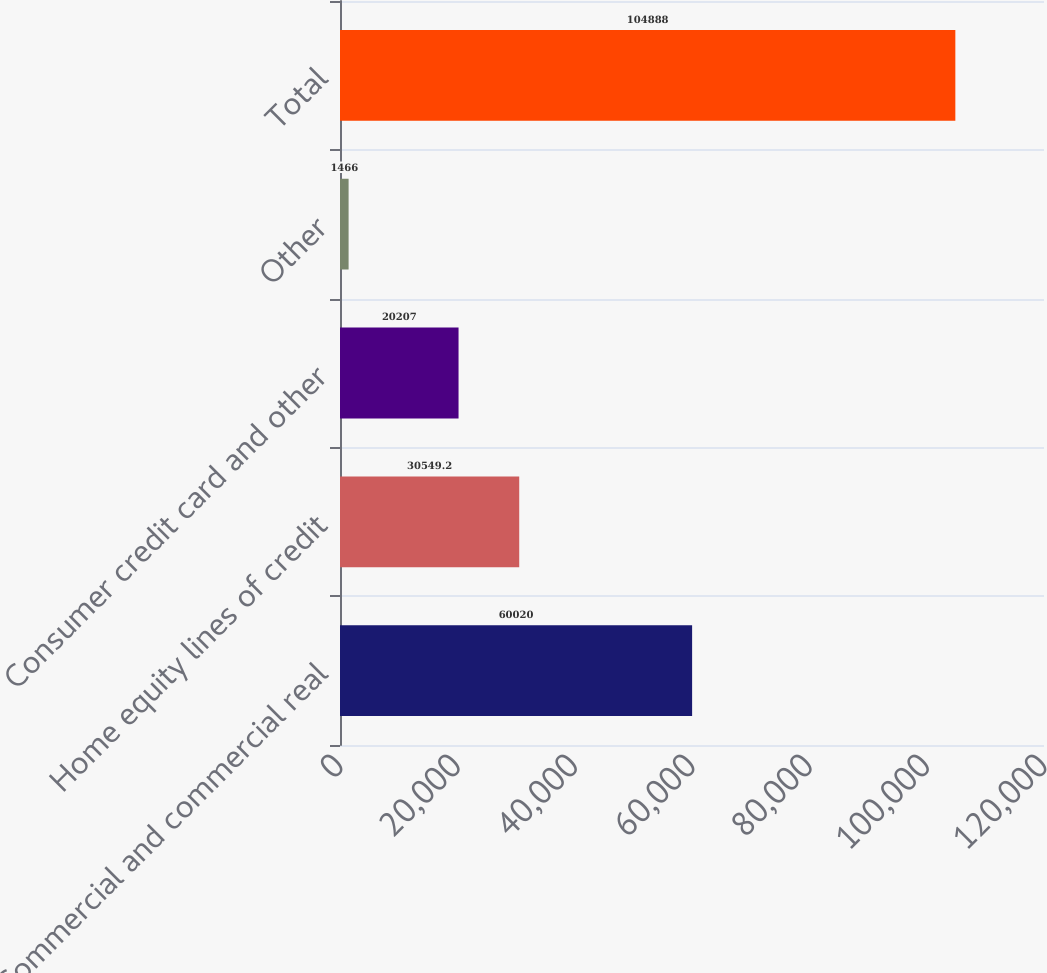Convert chart. <chart><loc_0><loc_0><loc_500><loc_500><bar_chart><fcel>Commercial and commercial real<fcel>Home equity lines of credit<fcel>Consumer credit card and other<fcel>Other<fcel>Total<nl><fcel>60020<fcel>30549.2<fcel>20207<fcel>1466<fcel>104888<nl></chart> 